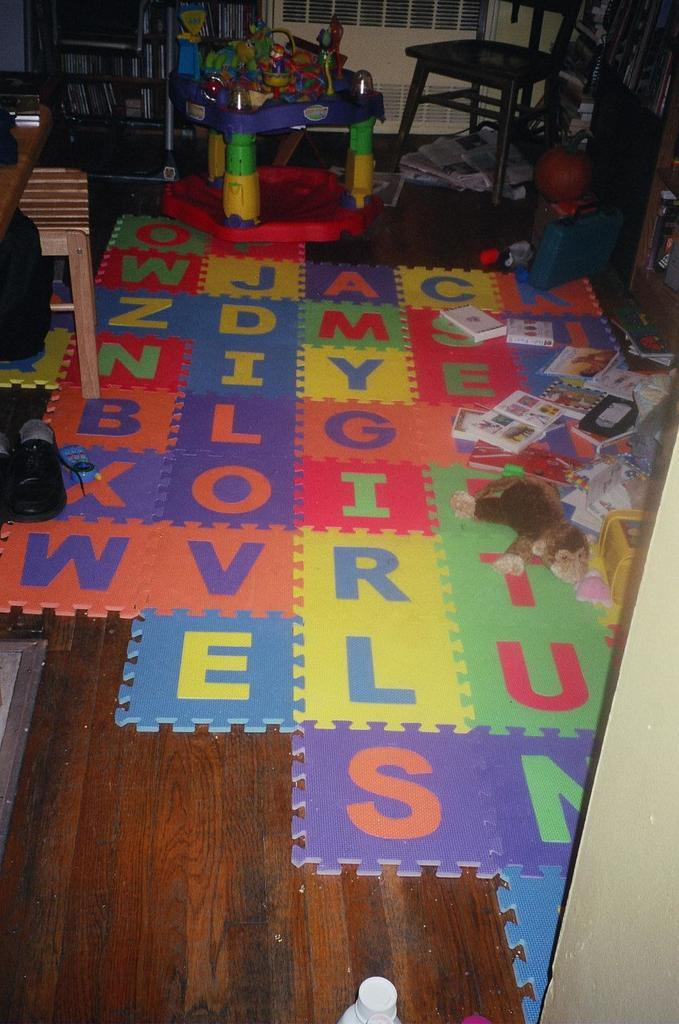What type of furniture is present in the image? There is a chair and a stool in the image. What items related to learning or reading can be seen in the image? There are papers, books, and racks in the image. What type of items might be used for play or entertainment in the image? There are toys and puzzle pieces in the image. What other objects can be seen in the image? There are other objects in the image, but their specific details are not mentioned in the provided facts. What is at the bottom of the image? There is a floor at the bottom of the image. How many dogs are present in the image? There are no dogs present in the image. What type of material is used to cover the chair in the image? The provided facts do not mention any information about the chair's covering material. 